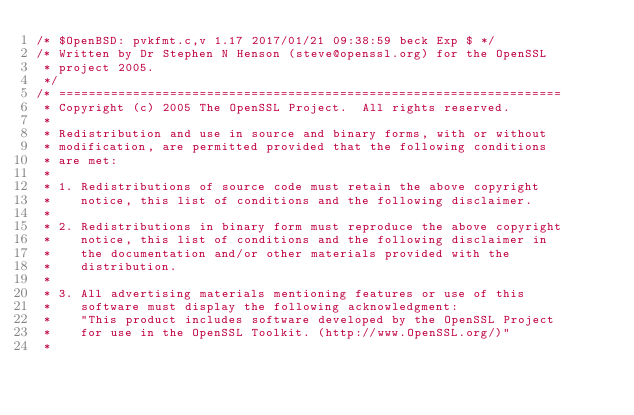Convert code to text. <code><loc_0><loc_0><loc_500><loc_500><_C_>/* $OpenBSD: pvkfmt.c,v 1.17 2017/01/21 09:38:59 beck Exp $ */
/* Written by Dr Stephen N Henson (steve@openssl.org) for the OpenSSL
 * project 2005.
 */
/* ====================================================================
 * Copyright (c) 2005 The OpenSSL Project.  All rights reserved.
 *
 * Redistribution and use in source and binary forms, with or without
 * modification, are permitted provided that the following conditions
 * are met:
 *
 * 1. Redistributions of source code must retain the above copyright
 *    notice, this list of conditions and the following disclaimer.
 *
 * 2. Redistributions in binary form must reproduce the above copyright
 *    notice, this list of conditions and the following disclaimer in
 *    the documentation and/or other materials provided with the
 *    distribution.
 *
 * 3. All advertising materials mentioning features or use of this
 *    software must display the following acknowledgment:
 *    "This product includes software developed by the OpenSSL Project
 *    for use in the OpenSSL Toolkit. (http://www.OpenSSL.org/)"
 *</code> 